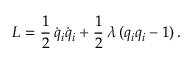<formula> <loc_0><loc_0><loc_500><loc_500>L = \frac { 1 } { 2 } \, \dot { q } _ { i } \dot { q } _ { i } + \frac { 1 } { 2 } \, \lambda \, ( q _ { i } q _ { i } - 1 ) \, .</formula> 